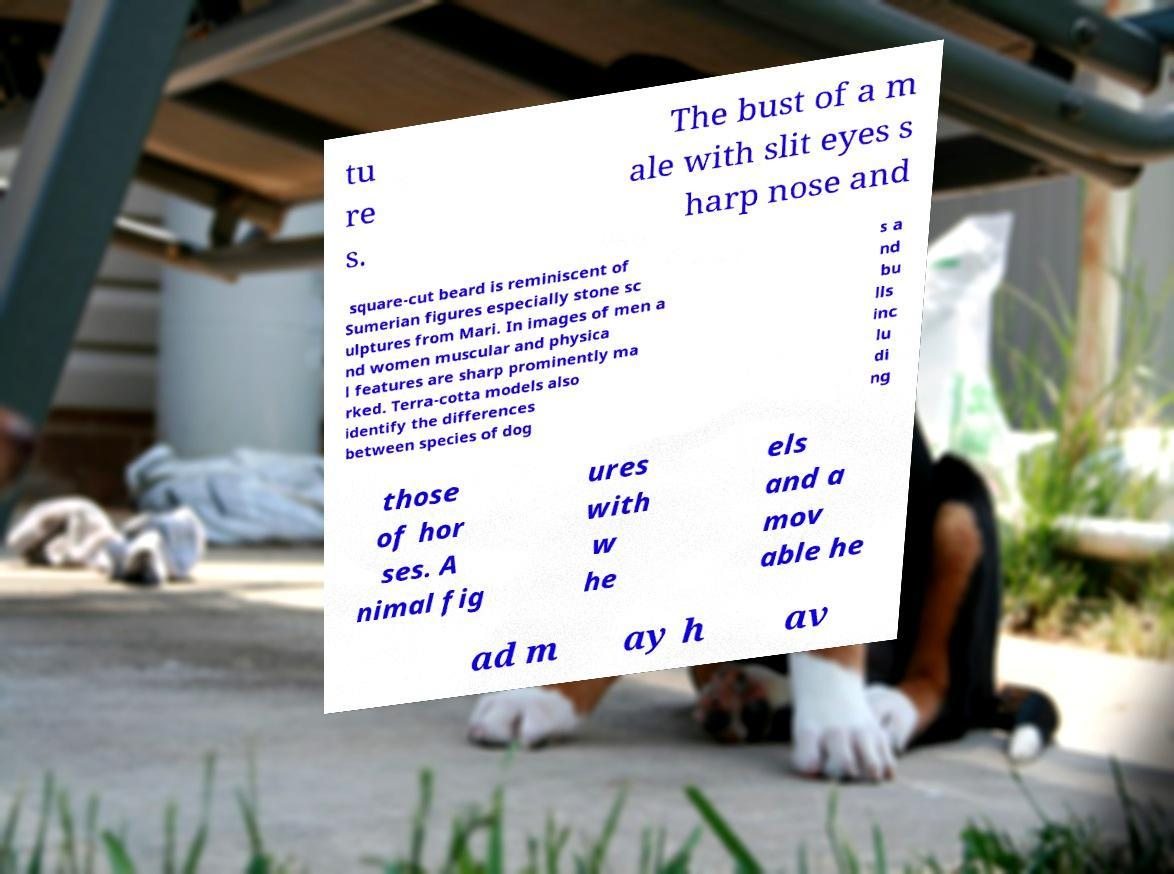Could you assist in decoding the text presented in this image and type it out clearly? tu re s. The bust of a m ale with slit eyes s harp nose and square-cut beard is reminiscent of Sumerian figures especially stone sc ulptures from Mari. In images of men a nd women muscular and physica l features are sharp prominently ma rked. Terra-cotta models also identify the differences between species of dog s a nd bu lls inc lu di ng those of hor ses. A nimal fig ures with w he els and a mov able he ad m ay h av 